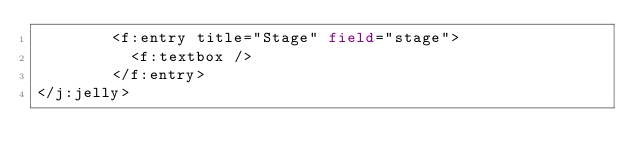Convert code to text. <code><loc_0><loc_0><loc_500><loc_500><_XML_>        <f:entry title="Stage" field="stage">
          <f:textbox />
        </f:entry>
</j:jelly></code> 